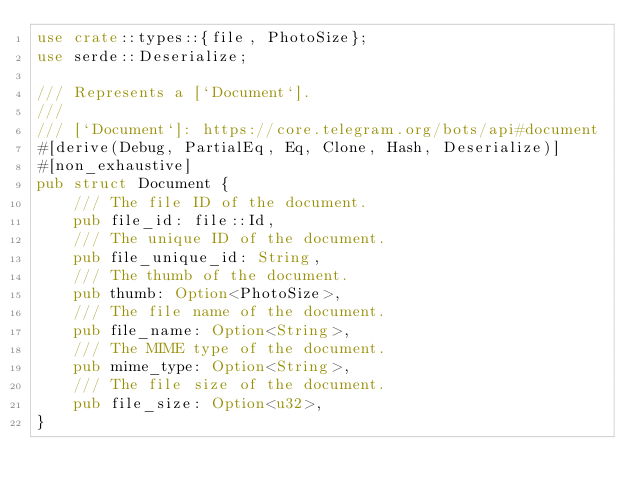<code> <loc_0><loc_0><loc_500><loc_500><_Rust_>use crate::types::{file, PhotoSize};
use serde::Deserialize;

/// Represents a [`Document`].
///
/// [`Document`]: https://core.telegram.org/bots/api#document
#[derive(Debug, PartialEq, Eq, Clone, Hash, Deserialize)]
#[non_exhaustive]
pub struct Document {
    /// The file ID of the document.
    pub file_id: file::Id,
    /// The unique ID of the document.
    pub file_unique_id: String,
    /// The thumb of the document.
    pub thumb: Option<PhotoSize>,
    /// The file name of the document.
    pub file_name: Option<String>,
    /// The MIME type of the document.
    pub mime_type: Option<String>,
    /// The file size of the document.
    pub file_size: Option<u32>,
}
</code> 